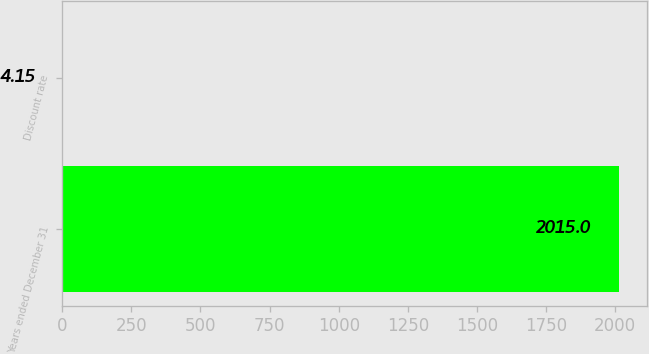Convert chart. <chart><loc_0><loc_0><loc_500><loc_500><bar_chart><fcel>Years ended December 31<fcel>Discount rate<nl><fcel>2015<fcel>4.15<nl></chart> 